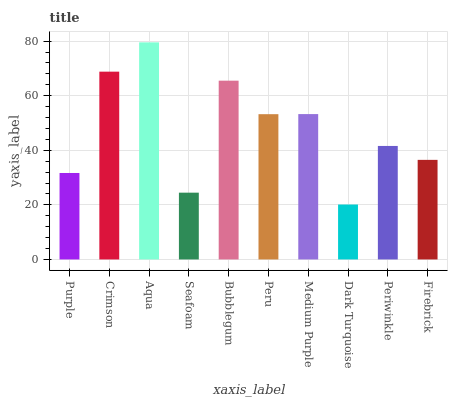Is Dark Turquoise the minimum?
Answer yes or no. Yes. Is Aqua the maximum?
Answer yes or no. Yes. Is Crimson the minimum?
Answer yes or no. No. Is Crimson the maximum?
Answer yes or no. No. Is Crimson greater than Purple?
Answer yes or no. Yes. Is Purple less than Crimson?
Answer yes or no. Yes. Is Purple greater than Crimson?
Answer yes or no. No. Is Crimson less than Purple?
Answer yes or no. No. Is Peru the high median?
Answer yes or no. Yes. Is Periwinkle the low median?
Answer yes or no. Yes. Is Aqua the high median?
Answer yes or no. No. Is Bubblegum the low median?
Answer yes or no. No. 